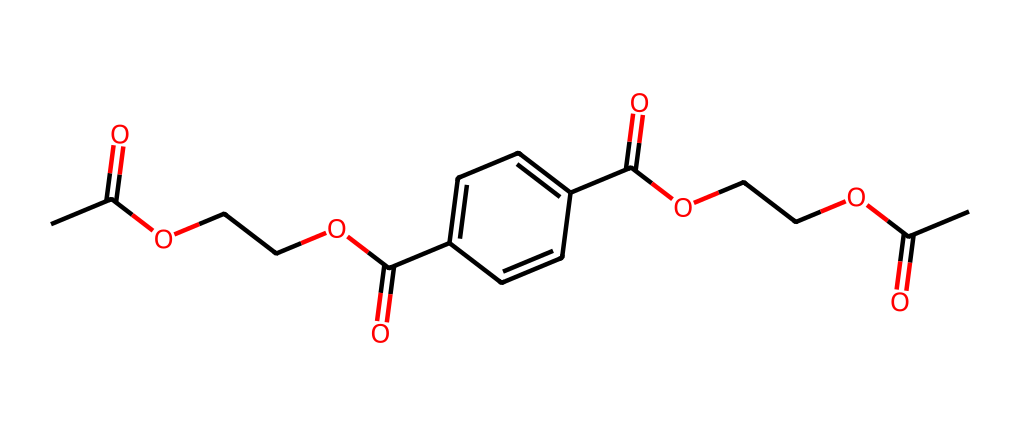What is the main functional group present in this chemical? The chemical contains multiple instances of the carboxylic acid functional group, indicated by the presence of the -COOH structure. This group is important for the properties of polyethylene terephthalate (PET).
Answer: carboxylic acid How many carbon atoms are in this molecule? By analyzing the SMILES representation, we identify the carbon atoms present in both the ester linkages and the aromatic ring. Counting all the carbon atoms results in a total of 16 carbon atoms.
Answer: 16 What type of polymer is represented by this chemical? The given chemical structure corresponds to polyethylene terephthalate (PET), which is a type of polyester polymer. The presence of ester functional groups indicates its polymeric nature.
Answer: polyester How many ester linkages are present in the structure? By examining the structure for the repeating units of the ester functional group (-COO-), we can identify that there are several ester linkages, specifically three in this molecule.
Answer: 3 What structural feature contributes to the rigidity of this polymer? The presence of the aromatic rings in the structure adds rigidity to the polymer chain due to the planar structure and strong π-π interactions between the rings.
Answer: aromatic rings What is the likely mechanical property of polyethylene terephthalate indicated by its structure? The combination of the crystalline regions from the ester linkages and the rigidity from the aromatic rings suggests that PET is likely to be strong and stiff, making it a suitable material for food delivery containers.
Answer: strong and stiff 